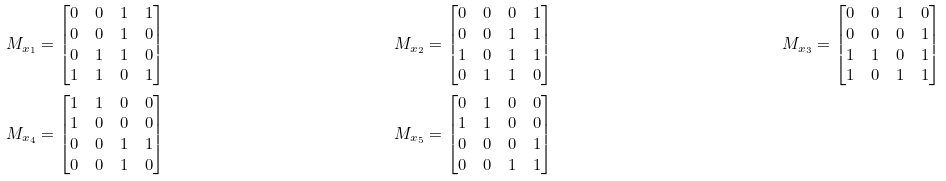<formula> <loc_0><loc_0><loc_500><loc_500>M _ { x _ { 1 } } & = \begin{bmatrix} 0 & 0 & 1 & 1 \\ 0 & 0 & 1 & 0 \\ 0 & 1 & 1 & 0 \\ 1 & 1 & 0 & 1 \end{bmatrix} & M _ { x _ { 2 } } & = \begin{bmatrix} 0 & 0 & 0 & 1 \\ 0 & 0 & 1 & 1 \\ 1 & 0 & 1 & 1 \\ 0 & 1 & 1 & 0 \end{bmatrix} & M _ { x _ { 3 } } & = \begin{bmatrix} 0 & 0 & 1 & 0 \\ 0 & 0 & 0 & 1 \\ 1 & 1 & 0 & 1 \\ 1 & 0 & 1 & 1 \end{bmatrix} \\ M _ { x _ { 4 } } & = \begin{bmatrix} 1 & 1 & 0 & 0 \\ 1 & 0 & 0 & 0 \\ 0 & 0 & 1 & 1 \\ 0 & 0 & 1 & 0 \end{bmatrix} & M _ { x _ { 5 } } & = \begin{bmatrix} 0 & 1 & 0 & 0 \\ 1 & 1 & 0 & 0 \\ 0 & 0 & 0 & 1 \\ 0 & 0 & 1 & 1 \end{bmatrix}</formula> 